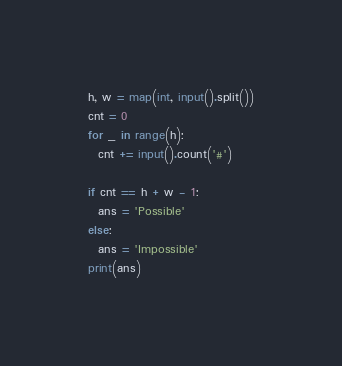Convert code to text. <code><loc_0><loc_0><loc_500><loc_500><_Python_>h, w = map(int, input().split())
cnt = 0
for _ in range(h):
  cnt += input().count('#')

if cnt == h + w - 1:
  ans = 'Possible'
else:
  ans = 'Impossible'
print(ans)</code> 